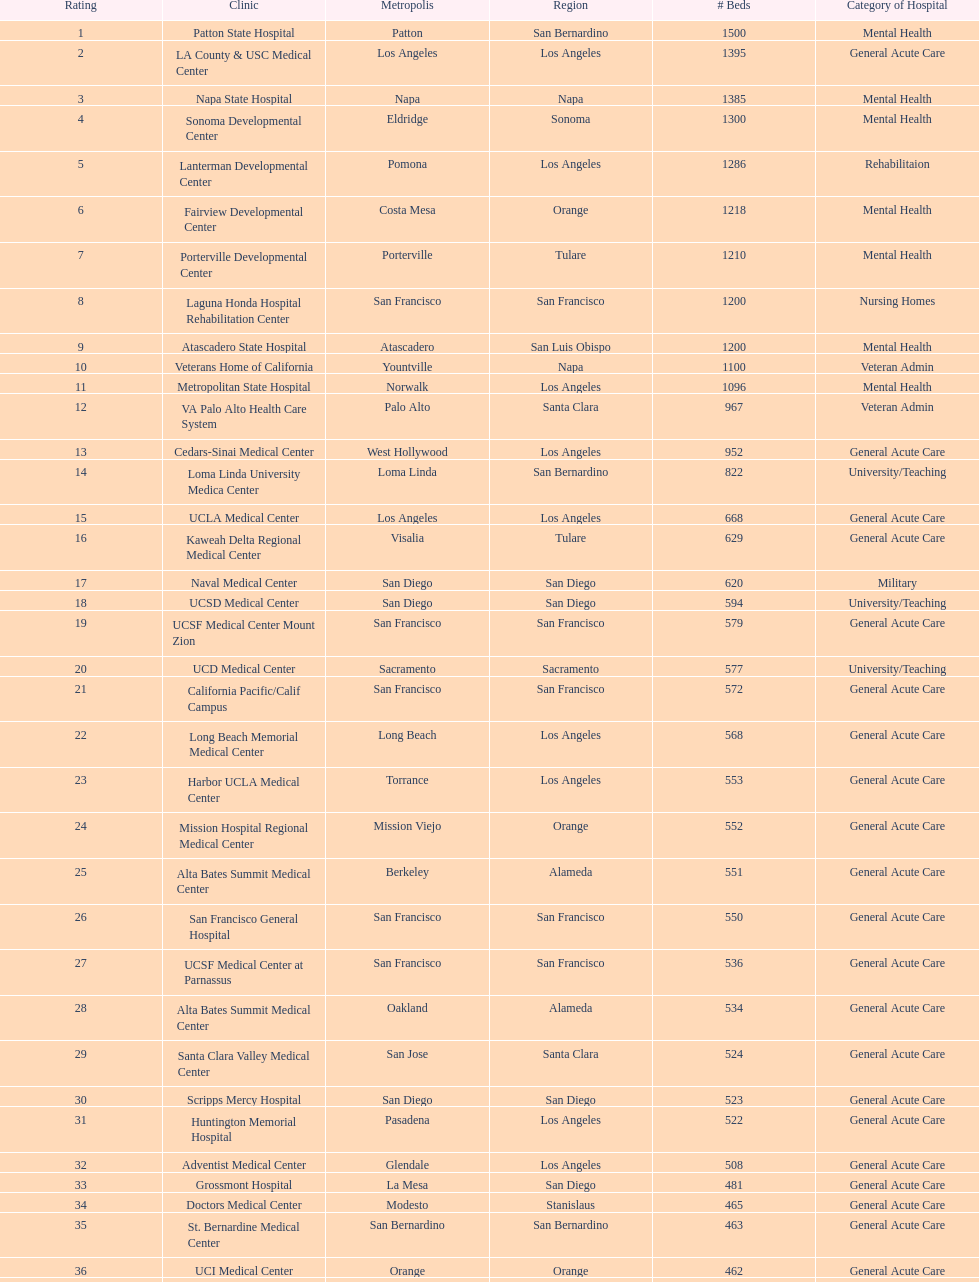What two hospitals holding consecutive rankings of 8 and 9 respectively, both provide 1200 hospital beds? Laguna Honda Hospital Rehabilitation Center, Atascadero State Hospital. 